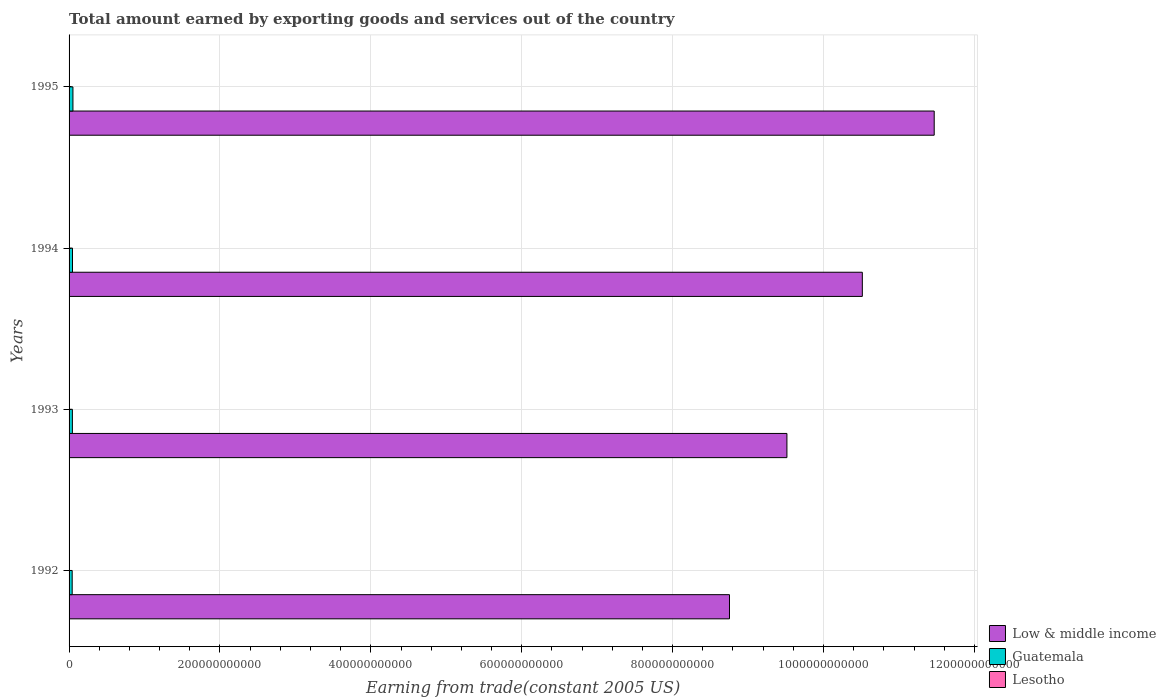How many different coloured bars are there?
Your response must be concise. 3. How many groups of bars are there?
Keep it short and to the point. 4. Are the number of bars per tick equal to the number of legend labels?
Keep it short and to the point. Yes. Are the number of bars on each tick of the Y-axis equal?
Give a very brief answer. Yes. What is the label of the 2nd group of bars from the top?
Provide a short and direct response. 1994. In how many cases, is the number of bars for a given year not equal to the number of legend labels?
Your answer should be very brief. 0. What is the total amount earned by exporting goods and services in Guatemala in 1995?
Provide a short and direct response. 5.12e+09. Across all years, what is the maximum total amount earned by exporting goods and services in Lesotho?
Your response must be concise. 2.08e+08. Across all years, what is the minimum total amount earned by exporting goods and services in Lesotho?
Ensure brevity in your answer.  1.36e+08. In which year was the total amount earned by exporting goods and services in Guatemala maximum?
Your answer should be very brief. 1995. What is the total total amount earned by exporting goods and services in Low & middle income in the graph?
Your response must be concise. 4.03e+12. What is the difference between the total amount earned by exporting goods and services in Low & middle income in 1992 and that in 1994?
Your answer should be very brief. -1.76e+11. What is the difference between the total amount earned by exporting goods and services in Low & middle income in 1992 and the total amount earned by exporting goods and services in Lesotho in 1995?
Make the answer very short. 8.75e+11. What is the average total amount earned by exporting goods and services in Guatemala per year?
Make the answer very short. 4.55e+09. In the year 1995, what is the difference between the total amount earned by exporting goods and services in Lesotho and total amount earned by exporting goods and services in Guatemala?
Provide a succinct answer. -4.91e+09. What is the ratio of the total amount earned by exporting goods and services in Lesotho in 1993 to that in 1995?
Offer a terse response. 0.86. Is the total amount earned by exporting goods and services in Guatemala in 1992 less than that in 1994?
Provide a succinct answer. Yes. Is the difference between the total amount earned by exporting goods and services in Lesotho in 1993 and 1994 greater than the difference between the total amount earned by exporting goods and services in Guatemala in 1993 and 1994?
Provide a succinct answer. Yes. What is the difference between the highest and the second highest total amount earned by exporting goods and services in Lesotho?
Your response must be concise. 2.20e+07. What is the difference between the highest and the lowest total amount earned by exporting goods and services in Low & middle income?
Your answer should be compact. 2.71e+11. In how many years, is the total amount earned by exporting goods and services in Guatemala greater than the average total amount earned by exporting goods and services in Guatemala taken over all years?
Provide a succinct answer. 1. What does the 2nd bar from the top in 1995 represents?
Offer a terse response. Guatemala. What does the 2nd bar from the bottom in 1994 represents?
Provide a short and direct response. Guatemala. How many bars are there?
Make the answer very short. 12. Are all the bars in the graph horizontal?
Ensure brevity in your answer.  Yes. What is the difference between two consecutive major ticks on the X-axis?
Ensure brevity in your answer.  2.00e+11. Does the graph contain grids?
Offer a very short reply. Yes. Where does the legend appear in the graph?
Ensure brevity in your answer.  Bottom right. How many legend labels are there?
Your response must be concise. 3. What is the title of the graph?
Offer a terse response. Total amount earned by exporting goods and services out of the country. What is the label or title of the X-axis?
Give a very brief answer. Earning from trade(constant 2005 US). What is the label or title of the Y-axis?
Make the answer very short. Years. What is the Earning from trade(constant 2005 US) of Low & middle income in 1992?
Offer a very short reply. 8.75e+11. What is the Earning from trade(constant 2005 US) in Guatemala in 1992?
Offer a very short reply. 4.13e+09. What is the Earning from trade(constant 2005 US) of Lesotho in 1992?
Provide a succinct answer. 1.36e+08. What is the Earning from trade(constant 2005 US) of Low & middle income in 1993?
Ensure brevity in your answer.  9.52e+11. What is the Earning from trade(constant 2005 US) of Guatemala in 1993?
Your response must be concise. 4.40e+09. What is the Earning from trade(constant 2005 US) in Lesotho in 1993?
Offer a terse response. 1.79e+08. What is the Earning from trade(constant 2005 US) of Low & middle income in 1994?
Provide a succinct answer. 1.05e+12. What is the Earning from trade(constant 2005 US) in Guatemala in 1994?
Give a very brief answer. 4.55e+09. What is the Earning from trade(constant 2005 US) in Lesotho in 1994?
Give a very brief answer. 1.86e+08. What is the Earning from trade(constant 2005 US) of Low & middle income in 1995?
Offer a very short reply. 1.15e+12. What is the Earning from trade(constant 2005 US) of Guatemala in 1995?
Your response must be concise. 5.12e+09. What is the Earning from trade(constant 2005 US) of Lesotho in 1995?
Your answer should be very brief. 2.08e+08. Across all years, what is the maximum Earning from trade(constant 2005 US) of Low & middle income?
Ensure brevity in your answer.  1.15e+12. Across all years, what is the maximum Earning from trade(constant 2005 US) of Guatemala?
Make the answer very short. 5.12e+09. Across all years, what is the maximum Earning from trade(constant 2005 US) in Lesotho?
Provide a succinct answer. 2.08e+08. Across all years, what is the minimum Earning from trade(constant 2005 US) in Low & middle income?
Provide a succinct answer. 8.75e+11. Across all years, what is the minimum Earning from trade(constant 2005 US) in Guatemala?
Provide a short and direct response. 4.13e+09. Across all years, what is the minimum Earning from trade(constant 2005 US) of Lesotho?
Your answer should be very brief. 1.36e+08. What is the total Earning from trade(constant 2005 US) in Low & middle income in the graph?
Your response must be concise. 4.03e+12. What is the total Earning from trade(constant 2005 US) in Guatemala in the graph?
Provide a short and direct response. 1.82e+1. What is the total Earning from trade(constant 2005 US) in Lesotho in the graph?
Your answer should be very brief. 7.08e+08. What is the difference between the Earning from trade(constant 2005 US) of Low & middle income in 1992 and that in 1993?
Your answer should be compact. -7.61e+1. What is the difference between the Earning from trade(constant 2005 US) of Guatemala in 1992 and that in 1993?
Offer a very short reply. -2.75e+08. What is the difference between the Earning from trade(constant 2005 US) in Lesotho in 1992 and that in 1993?
Ensure brevity in your answer.  -4.31e+07. What is the difference between the Earning from trade(constant 2005 US) in Low & middle income in 1992 and that in 1994?
Give a very brief answer. -1.76e+11. What is the difference between the Earning from trade(constant 2005 US) in Guatemala in 1992 and that in 1994?
Offer a terse response. -4.23e+08. What is the difference between the Earning from trade(constant 2005 US) in Lesotho in 1992 and that in 1994?
Provide a succinct answer. -5.04e+07. What is the difference between the Earning from trade(constant 2005 US) in Low & middle income in 1992 and that in 1995?
Provide a succinct answer. -2.71e+11. What is the difference between the Earning from trade(constant 2005 US) of Guatemala in 1992 and that in 1995?
Ensure brevity in your answer.  -9.95e+08. What is the difference between the Earning from trade(constant 2005 US) in Lesotho in 1992 and that in 1995?
Your answer should be very brief. -7.24e+07. What is the difference between the Earning from trade(constant 2005 US) of Low & middle income in 1993 and that in 1994?
Keep it short and to the point. -1.00e+11. What is the difference between the Earning from trade(constant 2005 US) in Guatemala in 1993 and that in 1994?
Give a very brief answer. -1.48e+08. What is the difference between the Earning from trade(constant 2005 US) of Lesotho in 1993 and that in 1994?
Give a very brief answer. -7.29e+06. What is the difference between the Earning from trade(constant 2005 US) in Low & middle income in 1993 and that in 1995?
Provide a succinct answer. -1.95e+11. What is the difference between the Earning from trade(constant 2005 US) of Guatemala in 1993 and that in 1995?
Provide a short and direct response. -7.19e+08. What is the difference between the Earning from trade(constant 2005 US) in Lesotho in 1993 and that in 1995?
Offer a terse response. -2.93e+07. What is the difference between the Earning from trade(constant 2005 US) of Low & middle income in 1994 and that in 1995?
Make the answer very short. -9.53e+1. What is the difference between the Earning from trade(constant 2005 US) in Guatemala in 1994 and that in 1995?
Keep it short and to the point. -5.71e+08. What is the difference between the Earning from trade(constant 2005 US) in Lesotho in 1994 and that in 1995?
Provide a short and direct response. -2.20e+07. What is the difference between the Earning from trade(constant 2005 US) in Low & middle income in 1992 and the Earning from trade(constant 2005 US) in Guatemala in 1993?
Your response must be concise. 8.71e+11. What is the difference between the Earning from trade(constant 2005 US) of Low & middle income in 1992 and the Earning from trade(constant 2005 US) of Lesotho in 1993?
Offer a terse response. 8.75e+11. What is the difference between the Earning from trade(constant 2005 US) of Guatemala in 1992 and the Earning from trade(constant 2005 US) of Lesotho in 1993?
Offer a very short reply. 3.95e+09. What is the difference between the Earning from trade(constant 2005 US) in Low & middle income in 1992 and the Earning from trade(constant 2005 US) in Guatemala in 1994?
Provide a succinct answer. 8.71e+11. What is the difference between the Earning from trade(constant 2005 US) of Low & middle income in 1992 and the Earning from trade(constant 2005 US) of Lesotho in 1994?
Ensure brevity in your answer.  8.75e+11. What is the difference between the Earning from trade(constant 2005 US) in Guatemala in 1992 and the Earning from trade(constant 2005 US) in Lesotho in 1994?
Your answer should be compact. 3.94e+09. What is the difference between the Earning from trade(constant 2005 US) in Low & middle income in 1992 and the Earning from trade(constant 2005 US) in Guatemala in 1995?
Give a very brief answer. 8.70e+11. What is the difference between the Earning from trade(constant 2005 US) in Low & middle income in 1992 and the Earning from trade(constant 2005 US) in Lesotho in 1995?
Your response must be concise. 8.75e+11. What is the difference between the Earning from trade(constant 2005 US) in Guatemala in 1992 and the Earning from trade(constant 2005 US) in Lesotho in 1995?
Keep it short and to the point. 3.92e+09. What is the difference between the Earning from trade(constant 2005 US) of Low & middle income in 1993 and the Earning from trade(constant 2005 US) of Guatemala in 1994?
Keep it short and to the point. 9.47e+11. What is the difference between the Earning from trade(constant 2005 US) of Low & middle income in 1993 and the Earning from trade(constant 2005 US) of Lesotho in 1994?
Provide a succinct answer. 9.51e+11. What is the difference between the Earning from trade(constant 2005 US) in Guatemala in 1993 and the Earning from trade(constant 2005 US) in Lesotho in 1994?
Your answer should be compact. 4.22e+09. What is the difference between the Earning from trade(constant 2005 US) in Low & middle income in 1993 and the Earning from trade(constant 2005 US) in Guatemala in 1995?
Provide a succinct answer. 9.46e+11. What is the difference between the Earning from trade(constant 2005 US) in Low & middle income in 1993 and the Earning from trade(constant 2005 US) in Lesotho in 1995?
Your answer should be very brief. 9.51e+11. What is the difference between the Earning from trade(constant 2005 US) of Guatemala in 1993 and the Earning from trade(constant 2005 US) of Lesotho in 1995?
Ensure brevity in your answer.  4.19e+09. What is the difference between the Earning from trade(constant 2005 US) in Low & middle income in 1994 and the Earning from trade(constant 2005 US) in Guatemala in 1995?
Give a very brief answer. 1.05e+12. What is the difference between the Earning from trade(constant 2005 US) of Low & middle income in 1994 and the Earning from trade(constant 2005 US) of Lesotho in 1995?
Your answer should be compact. 1.05e+12. What is the difference between the Earning from trade(constant 2005 US) of Guatemala in 1994 and the Earning from trade(constant 2005 US) of Lesotho in 1995?
Give a very brief answer. 4.34e+09. What is the average Earning from trade(constant 2005 US) of Low & middle income per year?
Make the answer very short. 1.01e+12. What is the average Earning from trade(constant 2005 US) of Guatemala per year?
Provide a succinct answer. 4.55e+09. What is the average Earning from trade(constant 2005 US) in Lesotho per year?
Make the answer very short. 1.77e+08. In the year 1992, what is the difference between the Earning from trade(constant 2005 US) in Low & middle income and Earning from trade(constant 2005 US) in Guatemala?
Offer a very short reply. 8.71e+11. In the year 1992, what is the difference between the Earning from trade(constant 2005 US) in Low & middle income and Earning from trade(constant 2005 US) in Lesotho?
Your response must be concise. 8.75e+11. In the year 1992, what is the difference between the Earning from trade(constant 2005 US) in Guatemala and Earning from trade(constant 2005 US) in Lesotho?
Ensure brevity in your answer.  3.99e+09. In the year 1993, what is the difference between the Earning from trade(constant 2005 US) of Low & middle income and Earning from trade(constant 2005 US) of Guatemala?
Offer a terse response. 9.47e+11. In the year 1993, what is the difference between the Earning from trade(constant 2005 US) in Low & middle income and Earning from trade(constant 2005 US) in Lesotho?
Your answer should be very brief. 9.51e+11. In the year 1993, what is the difference between the Earning from trade(constant 2005 US) of Guatemala and Earning from trade(constant 2005 US) of Lesotho?
Make the answer very short. 4.22e+09. In the year 1994, what is the difference between the Earning from trade(constant 2005 US) in Low & middle income and Earning from trade(constant 2005 US) in Guatemala?
Your response must be concise. 1.05e+12. In the year 1994, what is the difference between the Earning from trade(constant 2005 US) of Low & middle income and Earning from trade(constant 2005 US) of Lesotho?
Ensure brevity in your answer.  1.05e+12. In the year 1994, what is the difference between the Earning from trade(constant 2005 US) in Guatemala and Earning from trade(constant 2005 US) in Lesotho?
Your answer should be compact. 4.36e+09. In the year 1995, what is the difference between the Earning from trade(constant 2005 US) in Low & middle income and Earning from trade(constant 2005 US) in Guatemala?
Keep it short and to the point. 1.14e+12. In the year 1995, what is the difference between the Earning from trade(constant 2005 US) in Low & middle income and Earning from trade(constant 2005 US) in Lesotho?
Your answer should be very brief. 1.15e+12. In the year 1995, what is the difference between the Earning from trade(constant 2005 US) in Guatemala and Earning from trade(constant 2005 US) in Lesotho?
Offer a terse response. 4.91e+09. What is the ratio of the Earning from trade(constant 2005 US) in Low & middle income in 1992 to that in 1993?
Offer a very short reply. 0.92. What is the ratio of the Earning from trade(constant 2005 US) of Guatemala in 1992 to that in 1993?
Your answer should be compact. 0.94. What is the ratio of the Earning from trade(constant 2005 US) of Lesotho in 1992 to that in 1993?
Provide a succinct answer. 0.76. What is the ratio of the Earning from trade(constant 2005 US) of Low & middle income in 1992 to that in 1994?
Offer a terse response. 0.83. What is the ratio of the Earning from trade(constant 2005 US) of Guatemala in 1992 to that in 1994?
Offer a very short reply. 0.91. What is the ratio of the Earning from trade(constant 2005 US) of Lesotho in 1992 to that in 1994?
Your response must be concise. 0.73. What is the ratio of the Earning from trade(constant 2005 US) of Low & middle income in 1992 to that in 1995?
Provide a succinct answer. 0.76. What is the ratio of the Earning from trade(constant 2005 US) of Guatemala in 1992 to that in 1995?
Ensure brevity in your answer.  0.81. What is the ratio of the Earning from trade(constant 2005 US) in Lesotho in 1992 to that in 1995?
Your answer should be very brief. 0.65. What is the ratio of the Earning from trade(constant 2005 US) in Low & middle income in 1993 to that in 1994?
Your response must be concise. 0.9. What is the ratio of the Earning from trade(constant 2005 US) in Guatemala in 1993 to that in 1994?
Offer a terse response. 0.97. What is the ratio of the Earning from trade(constant 2005 US) in Lesotho in 1993 to that in 1994?
Make the answer very short. 0.96. What is the ratio of the Earning from trade(constant 2005 US) in Low & middle income in 1993 to that in 1995?
Give a very brief answer. 0.83. What is the ratio of the Earning from trade(constant 2005 US) of Guatemala in 1993 to that in 1995?
Offer a terse response. 0.86. What is the ratio of the Earning from trade(constant 2005 US) of Lesotho in 1993 to that in 1995?
Make the answer very short. 0.86. What is the ratio of the Earning from trade(constant 2005 US) in Low & middle income in 1994 to that in 1995?
Provide a succinct answer. 0.92. What is the ratio of the Earning from trade(constant 2005 US) in Guatemala in 1994 to that in 1995?
Provide a succinct answer. 0.89. What is the ratio of the Earning from trade(constant 2005 US) of Lesotho in 1994 to that in 1995?
Your answer should be compact. 0.89. What is the difference between the highest and the second highest Earning from trade(constant 2005 US) of Low & middle income?
Ensure brevity in your answer.  9.53e+1. What is the difference between the highest and the second highest Earning from trade(constant 2005 US) in Guatemala?
Provide a succinct answer. 5.71e+08. What is the difference between the highest and the second highest Earning from trade(constant 2005 US) in Lesotho?
Ensure brevity in your answer.  2.20e+07. What is the difference between the highest and the lowest Earning from trade(constant 2005 US) of Low & middle income?
Give a very brief answer. 2.71e+11. What is the difference between the highest and the lowest Earning from trade(constant 2005 US) of Guatemala?
Your answer should be very brief. 9.95e+08. What is the difference between the highest and the lowest Earning from trade(constant 2005 US) of Lesotho?
Give a very brief answer. 7.24e+07. 